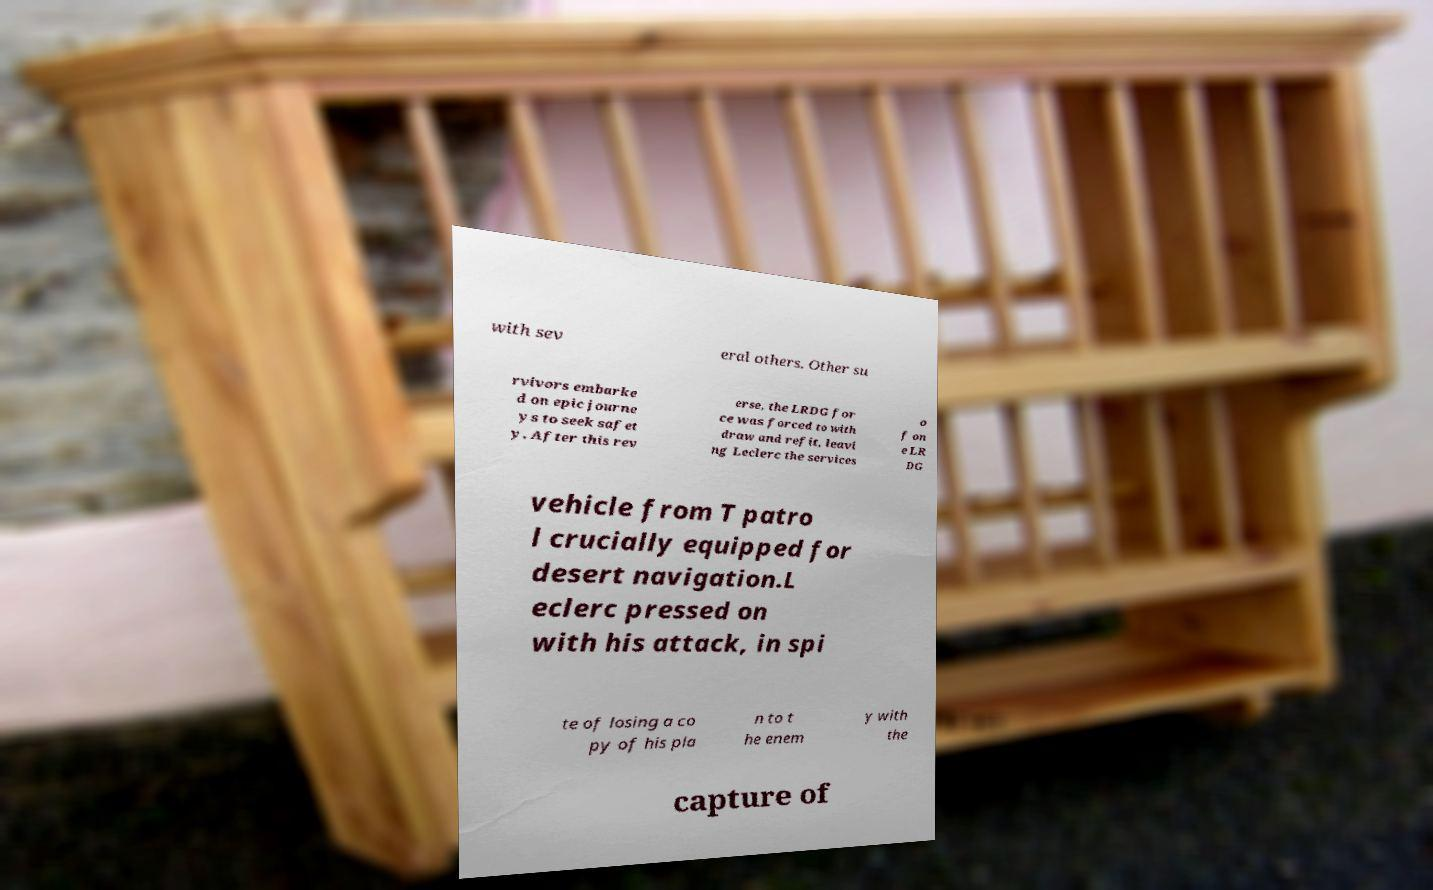Could you extract and type out the text from this image? with sev eral others. Other su rvivors embarke d on epic journe ys to seek safet y. After this rev erse, the LRDG for ce was forced to with draw and refit, leavi ng Leclerc the services o f on e LR DG vehicle from T patro l crucially equipped for desert navigation.L eclerc pressed on with his attack, in spi te of losing a co py of his pla n to t he enem y with the capture of 